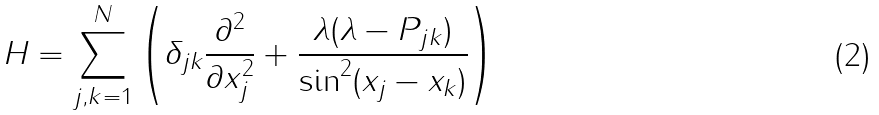<formula> <loc_0><loc_0><loc_500><loc_500>H = \sum _ { j , k = 1 } ^ { N } \left ( \delta _ { j k } \frac { \partial ^ { 2 } } { \partial x _ { j } ^ { 2 } } + \frac { \lambda ( \lambda - P _ { j k } ) } { \sin ^ { 2 } ( x _ { j } - x _ { k } ) } \right )</formula> 